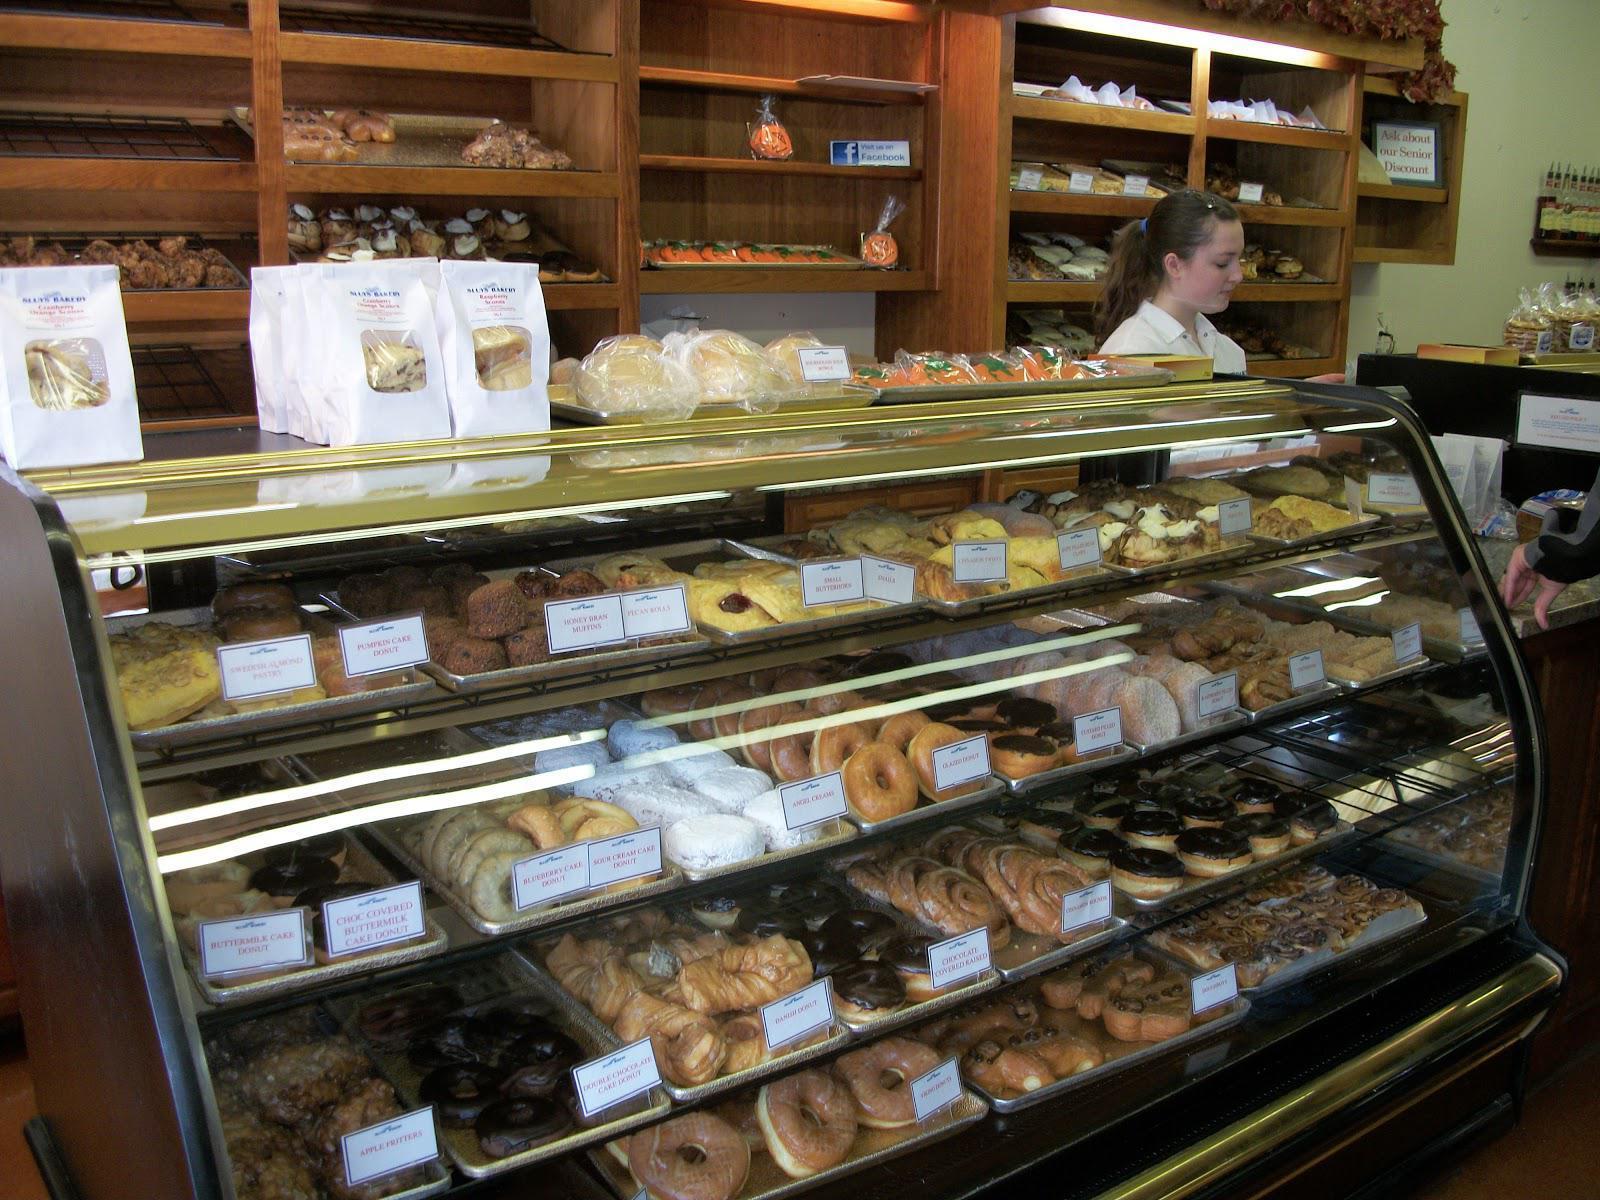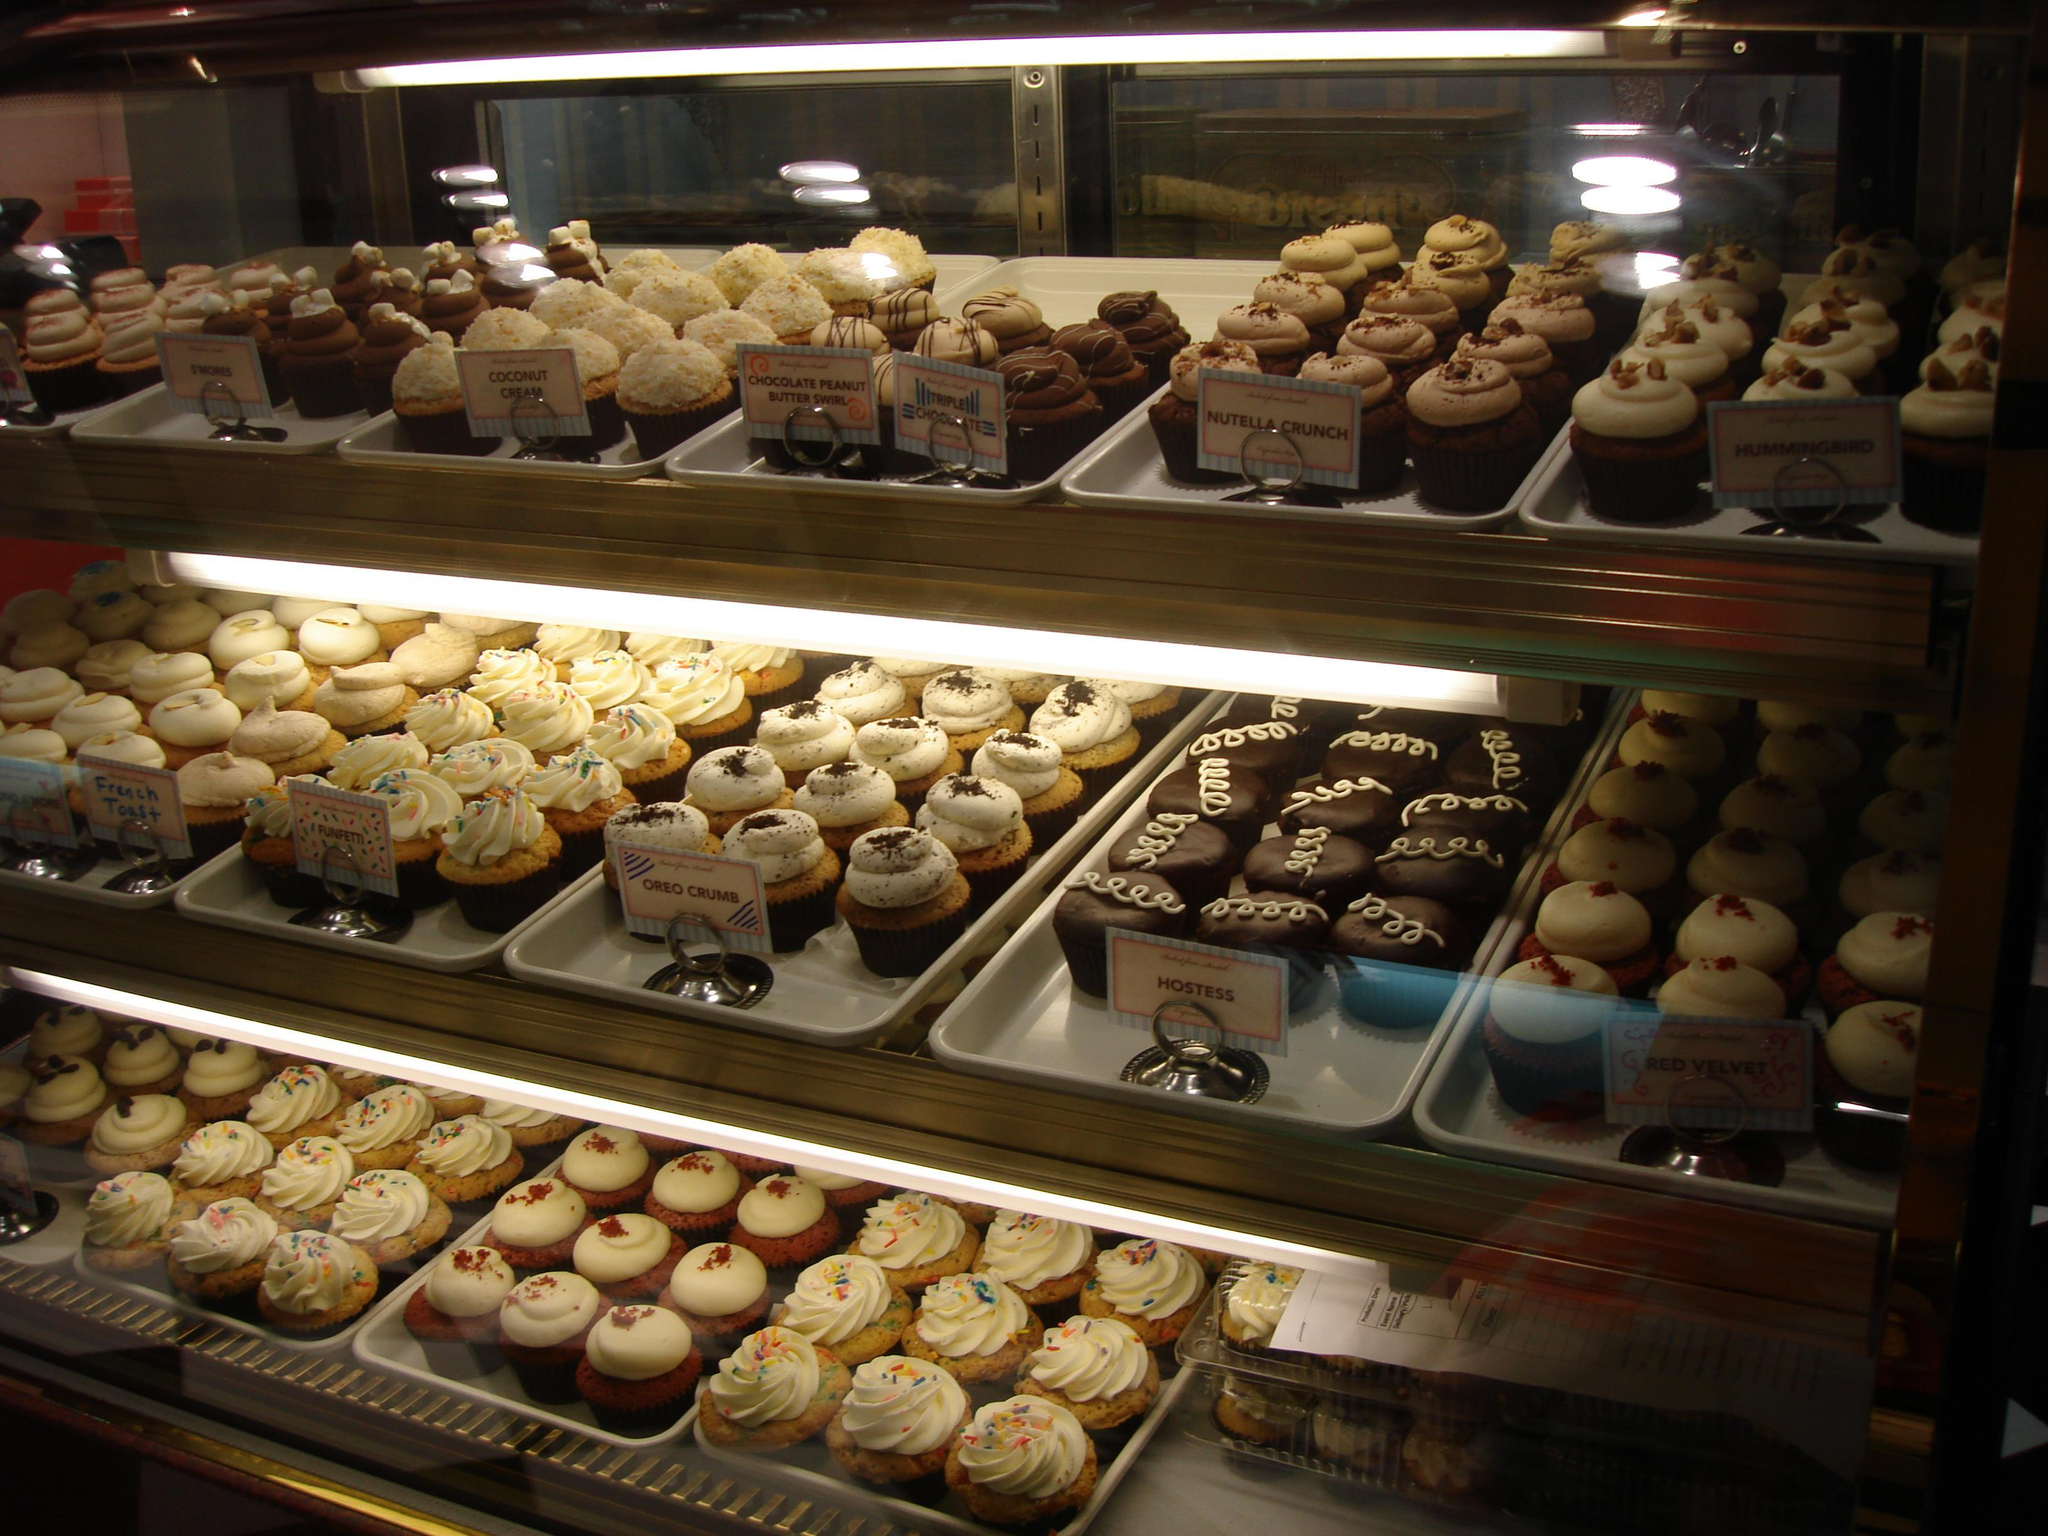The first image is the image on the left, the second image is the image on the right. Assess this claim about the two images: "Both displays contain three shelves.". Correct or not? Answer yes or no. No. The first image is the image on the left, the second image is the image on the right. Considering the images on both sides, is "In one image, a person is behind a curved, glass-fronted display with white packages on its top." valid? Answer yes or no. Yes. 